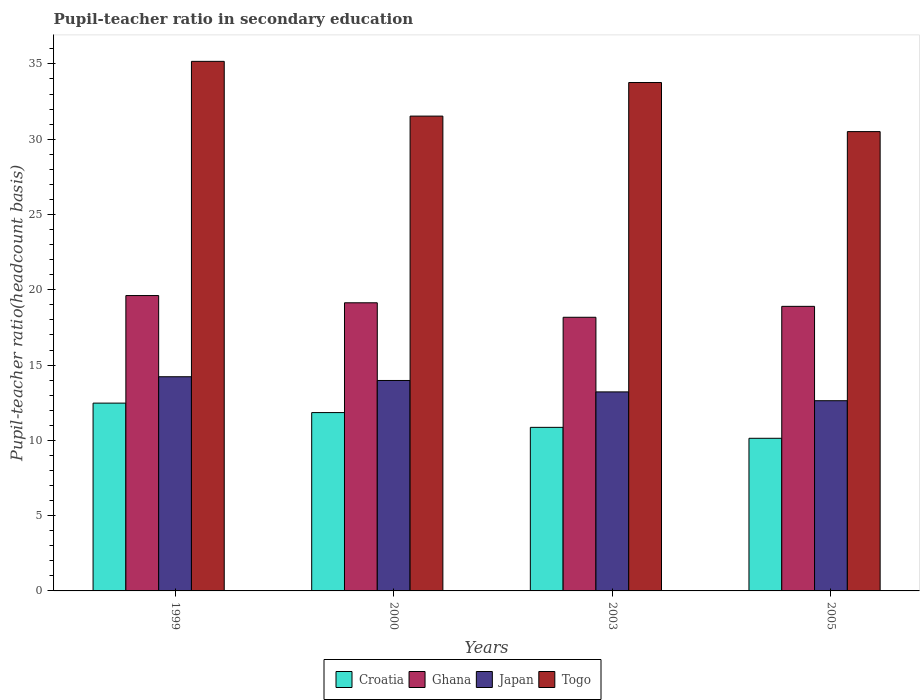Are the number of bars per tick equal to the number of legend labels?
Offer a terse response. Yes. Are the number of bars on each tick of the X-axis equal?
Offer a very short reply. Yes. How many bars are there on the 1st tick from the left?
Provide a short and direct response. 4. How many bars are there on the 3rd tick from the right?
Your response must be concise. 4. In how many cases, is the number of bars for a given year not equal to the number of legend labels?
Give a very brief answer. 0. What is the pupil-teacher ratio in secondary education in Croatia in 2003?
Ensure brevity in your answer.  10.86. Across all years, what is the maximum pupil-teacher ratio in secondary education in Japan?
Offer a terse response. 14.22. Across all years, what is the minimum pupil-teacher ratio in secondary education in Ghana?
Provide a succinct answer. 18.17. What is the total pupil-teacher ratio in secondary education in Japan in the graph?
Keep it short and to the point. 54.05. What is the difference between the pupil-teacher ratio in secondary education in Ghana in 1999 and that in 2005?
Ensure brevity in your answer.  0.72. What is the difference between the pupil-teacher ratio in secondary education in Croatia in 2003 and the pupil-teacher ratio in secondary education in Togo in 2005?
Provide a succinct answer. -19.64. What is the average pupil-teacher ratio in secondary education in Togo per year?
Make the answer very short. 32.74. In the year 2000, what is the difference between the pupil-teacher ratio in secondary education in Japan and pupil-teacher ratio in secondary education in Ghana?
Your answer should be very brief. -5.16. What is the ratio of the pupil-teacher ratio in secondary education in Japan in 2003 to that in 2005?
Make the answer very short. 1.05. What is the difference between the highest and the second highest pupil-teacher ratio in secondary education in Togo?
Offer a terse response. 1.41. What is the difference between the highest and the lowest pupil-teacher ratio in secondary education in Japan?
Provide a succinct answer. 1.59. In how many years, is the pupil-teacher ratio in secondary education in Ghana greater than the average pupil-teacher ratio in secondary education in Ghana taken over all years?
Keep it short and to the point. 2. What does the 3rd bar from the left in 2000 represents?
Your response must be concise. Japan. How many years are there in the graph?
Ensure brevity in your answer.  4. Does the graph contain any zero values?
Provide a short and direct response. No. Where does the legend appear in the graph?
Your answer should be very brief. Bottom center. How many legend labels are there?
Your response must be concise. 4. What is the title of the graph?
Make the answer very short. Pupil-teacher ratio in secondary education. Does "Marshall Islands" appear as one of the legend labels in the graph?
Provide a short and direct response. No. What is the label or title of the Y-axis?
Keep it short and to the point. Pupil-teacher ratio(headcount basis). What is the Pupil-teacher ratio(headcount basis) of Croatia in 1999?
Offer a very short reply. 12.47. What is the Pupil-teacher ratio(headcount basis) in Ghana in 1999?
Provide a succinct answer. 19.62. What is the Pupil-teacher ratio(headcount basis) of Japan in 1999?
Offer a terse response. 14.22. What is the Pupil-teacher ratio(headcount basis) in Togo in 1999?
Ensure brevity in your answer.  35.17. What is the Pupil-teacher ratio(headcount basis) of Croatia in 2000?
Give a very brief answer. 11.84. What is the Pupil-teacher ratio(headcount basis) in Ghana in 2000?
Make the answer very short. 19.14. What is the Pupil-teacher ratio(headcount basis) in Japan in 2000?
Offer a terse response. 13.98. What is the Pupil-teacher ratio(headcount basis) of Togo in 2000?
Make the answer very short. 31.53. What is the Pupil-teacher ratio(headcount basis) of Croatia in 2003?
Make the answer very short. 10.86. What is the Pupil-teacher ratio(headcount basis) of Ghana in 2003?
Give a very brief answer. 18.17. What is the Pupil-teacher ratio(headcount basis) in Japan in 2003?
Keep it short and to the point. 13.22. What is the Pupil-teacher ratio(headcount basis) of Togo in 2003?
Your answer should be compact. 33.76. What is the Pupil-teacher ratio(headcount basis) of Croatia in 2005?
Your response must be concise. 10.14. What is the Pupil-teacher ratio(headcount basis) of Ghana in 2005?
Offer a very short reply. 18.9. What is the Pupil-teacher ratio(headcount basis) of Japan in 2005?
Offer a very short reply. 12.63. What is the Pupil-teacher ratio(headcount basis) of Togo in 2005?
Offer a terse response. 30.51. Across all years, what is the maximum Pupil-teacher ratio(headcount basis) of Croatia?
Your answer should be very brief. 12.47. Across all years, what is the maximum Pupil-teacher ratio(headcount basis) in Ghana?
Provide a succinct answer. 19.62. Across all years, what is the maximum Pupil-teacher ratio(headcount basis) in Japan?
Make the answer very short. 14.22. Across all years, what is the maximum Pupil-teacher ratio(headcount basis) in Togo?
Ensure brevity in your answer.  35.17. Across all years, what is the minimum Pupil-teacher ratio(headcount basis) in Croatia?
Ensure brevity in your answer.  10.14. Across all years, what is the minimum Pupil-teacher ratio(headcount basis) in Ghana?
Offer a terse response. 18.17. Across all years, what is the minimum Pupil-teacher ratio(headcount basis) in Japan?
Give a very brief answer. 12.63. Across all years, what is the minimum Pupil-teacher ratio(headcount basis) of Togo?
Your response must be concise. 30.51. What is the total Pupil-teacher ratio(headcount basis) of Croatia in the graph?
Your response must be concise. 45.32. What is the total Pupil-teacher ratio(headcount basis) of Ghana in the graph?
Your answer should be compact. 75.83. What is the total Pupil-teacher ratio(headcount basis) of Japan in the graph?
Your answer should be compact. 54.05. What is the total Pupil-teacher ratio(headcount basis) of Togo in the graph?
Ensure brevity in your answer.  130.97. What is the difference between the Pupil-teacher ratio(headcount basis) in Croatia in 1999 and that in 2000?
Give a very brief answer. 0.63. What is the difference between the Pupil-teacher ratio(headcount basis) in Ghana in 1999 and that in 2000?
Keep it short and to the point. 0.48. What is the difference between the Pupil-teacher ratio(headcount basis) of Japan in 1999 and that in 2000?
Keep it short and to the point. 0.25. What is the difference between the Pupil-teacher ratio(headcount basis) of Togo in 1999 and that in 2000?
Provide a short and direct response. 3.64. What is the difference between the Pupil-teacher ratio(headcount basis) in Croatia in 1999 and that in 2003?
Give a very brief answer. 1.61. What is the difference between the Pupil-teacher ratio(headcount basis) in Ghana in 1999 and that in 2003?
Provide a succinct answer. 1.44. What is the difference between the Pupil-teacher ratio(headcount basis) of Togo in 1999 and that in 2003?
Your response must be concise. 1.41. What is the difference between the Pupil-teacher ratio(headcount basis) of Croatia in 1999 and that in 2005?
Offer a very short reply. 2.34. What is the difference between the Pupil-teacher ratio(headcount basis) of Ghana in 1999 and that in 2005?
Your answer should be very brief. 0.72. What is the difference between the Pupil-teacher ratio(headcount basis) of Japan in 1999 and that in 2005?
Your response must be concise. 1.59. What is the difference between the Pupil-teacher ratio(headcount basis) of Togo in 1999 and that in 2005?
Your response must be concise. 4.67. What is the difference between the Pupil-teacher ratio(headcount basis) of Croatia in 2000 and that in 2003?
Make the answer very short. 0.98. What is the difference between the Pupil-teacher ratio(headcount basis) of Ghana in 2000 and that in 2003?
Keep it short and to the point. 0.96. What is the difference between the Pupil-teacher ratio(headcount basis) in Japan in 2000 and that in 2003?
Ensure brevity in your answer.  0.76. What is the difference between the Pupil-teacher ratio(headcount basis) of Togo in 2000 and that in 2003?
Offer a very short reply. -2.23. What is the difference between the Pupil-teacher ratio(headcount basis) of Croatia in 2000 and that in 2005?
Provide a short and direct response. 1.71. What is the difference between the Pupil-teacher ratio(headcount basis) in Ghana in 2000 and that in 2005?
Provide a short and direct response. 0.24. What is the difference between the Pupil-teacher ratio(headcount basis) in Japan in 2000 and that in 2005?
Your response must be concise. 1.34. What is the difference between the Pupil-teacher ratio(headcount basis) in Togo in 2000 and that in 2005?
Ensure brevity in your answer.  1.03. What is the difference between the Pupil-teacher ratio(headcount basis) of Croatia in 2003 and that in 2005?
Provide a short and direct response. 0.73. What is the difference between the Pupil-teacher ratio(headcount basis) in Ghana in 2003 and that in 2005?
Give a very brief answer. -0.73. What is the difference between the Pupil-teacher ratio(headcount basis) of Japan in 2003 and that in 2005?
Give a very brief answer. 0.59. What is the difference between the Pupil-teacher ratio(headcount basis) of Togo in 2003 and that in 2005?
Provide a succinct answer. 3.26. What is the difference between the Pupil-teacher ratio(headcount basis) of Croatia in 1999 and the Pupil-teacher ratio(headcount basis) of Ghana in 2000?
Offer a very short reply. -6.66. What is the difference between the Pupil-teacher ratio(headcount basis) in Croatia in 1999 and the Pupil-teacher ratio(headcount basis) in Japan in 2000?
Make the answer very short. -1.5. What is the difference between the Pupil-teacher ratio(headcount basis) in Croatia in 1999 and the Pupil-teacher ratio(headcount basis) in Togo in 2000?
Your response must be concise. -19.06. What is the difference between the Pupil-teacher ratio(headcount basis) in Ghana in 1999 and the Pupil-teacher ratio(headcount basis) in Japan in 2000?
Provide a succinct answer. 5.64. What is the difference between the Pupil-teacher ratio(headcount basis) in Ghana in 1999 and the Pupil-teacher ratio(headcount basis) in Togo in 2000?
Your answer should be very brief. -11.92. What is the difference between the Pupil-teacher ratio(headcount basis) in Japan in 1999 and the Pupil-teacher ratio(headcount basis) in Togo in 2000?
Give a very brief answer. -17.31. What is the difference between the Pupil-teacher ratio(headcount basis) of Croatia in 1999 and the Pupil-teacher ratio(headcount basis) of Ghana in 2003?
Give a very brief answer. -5.7. What is the difference between the Pupil-teacher ratio(headcount basis) in Croatia in 1999 and the Pupil-teacher ratio(headcount basis) in Japan in 2003?
Make the answer very short. -0.75. What is the difference between the Pupil-teacher ratio(headcount basis) in Croatia in 1999 and the Pupil-teacher ratio(headcount basis) in Togo in 2003?
Provide a short and direct response. -21.29. What is the difference between the Pupil-teacher ratio(headcount basis) in Ghana in 1999 and the Pupil-teacher ratio(headcount basis) in Japan in 2003?
Provide a succinct answer. 6.4. What is the difference between the Pupil-teacher ratio(headcount basis) of Ghana in 1999 and the Pupil-teacher ratio(headcount basis) of Togo in 2003?
Give a very brief answer. -14.15. What is the difference between the Pupil-teacher ratio(headcount basis) in Japan in 1999 and the Pupil-teacher ratio(headcount basis) in Togo in 2003?
Give a very brief answer. -19.54. What is the difference between the Pupil-teacher ratio(headcount basis) of Croatia in 1999 and the Pupil-teacher ratio(headcount basis) of Ghana in 2005?
Provide a short and direct response. -6.43. What is the difference between the Pupil-teacher ratio(headcount basis) of Croatia in 1999 and the Pupil-teacher ratio(headcount basis) of Japan in 2005?
Your response must be concise. -0.16. What is the difference between the Pupil-teacher ratio(headcount basis) in Croatia in 1999 and the Pupil-teacher ratio(headcount basis) in Togo in 2005?
Your answer should be compact. -18.03. What is the difference between the Pupil-teacher ratio(headcount basis) of Ghana in 1999 and the Pupil-teacher ratio(headcount basis) of Japan in 2005?
Offer a very short reply. 6.98. What is the difference between the Pupil-teacher ratio(headcount basis) of Ghana in 1999 and the Pupil-teacher ratio(headcount basis) of Togo in 2005?
Keep it short and to the point. -10.89. What is the difference between the Pupil-teacher ratio(headcount basis) of Japan in 1999 and the Pupil-teacher ratio(headcount basis) of Togo in 2005?
Provide a short and direct response. -16.28. What is the difference between the Pupil-teacher ratio(headcount basis) of Croatia in 2000 and the Pupil-teacher ratio(headcount basis) of Ghana in 2003?
Provide a succinct answer. -6.33. What is the difference between the Pupil-teacher ratio(headcount basis) of Croatia in 2000 and the Pupil-teacher ratio(headcount basis) of Japan in 2003?
Offer a terse response. -1.37. What is the difference between the Pupil-teacher ratio(headcount basis) of Croatia in 2000 and the Pupil-teacher ratio(headcount basis) of Togo in 2003?
Offer a very short reply. -21.92. What is the difference between the Pupil-teacher ratio(headcount basis) in Ghana in 2000 and the Pupil-teacher ratio(headcount basis) in Japan in 2003?
Make the answer very short. 5.92. What is the difference between the Pupil-teacher ratio(headcount basis) in Ghana in 2000 and the Pupil-teacher ratio(headcount basis) in Togo in 2003?
Ensure brevity in your answer.  -14.63. What is the difference between the Pupil-teacher ratio(headcount basis) in Japan in 2000 and the Pupil-teacher ratio(headcount basis) in Togo in 2003?
Your answer should be compact. -19.79. What is the difference between the Pupil-teacher ratio(headcount basis) in Croatia in 2000 and the Pupil-teacher ratio(headcount basis) in Ghana in 2005?
Provide a succinct answer. -7.06. What is the difference between the Pupil-teacher ratio(headcount basis) in Croatia in 2000 and the Pupil-teacher ratio(headcount basis) in Japan in 2005?
Offer a terse response. -0.79. What is the difference between the Pupil-teacher ratio(headcount basis) of Croatia in 2000 and the Pupil-teacher ratio(headcount basis) of Togo in 2005?
Your response must be concise. -18.66. What is the difference between the Pupil-teacher ratio(headcount basis) in Ghana in 2000 and the Pupil-teacher ratio(headcount basis) in Japan in 2005?
Provide a succinct answer. 6.5. What is the difference between the Pupil-teacher ratio(headcount basis) in Ghana in 2000 and the Pupil-teacher ratio(headcount basis) in Togo in 2005?
Offer a terse response. -11.37. What is the difference between the Pupil-teacher ratio(headcount basis) of Japan in 2000 and the Pupil-teacher ratio(headcount basis) of Togo in 2005?
Make the answer very short. -16.53. What is the difference between the Pupil-teacher ratio(headcount basis) in Croatia in 2003 and the Pupil-teacher ratio(headcount basis) in Ghana in 2005?
Give a very brief answer. -8.04. What is the difference between the Pupil-teacher ratio(headcount basis) of Croatia in 2003 and the Pupil-teacher ratio(headcount basis) of Japan in 2005?
Provide a succinct answer. -1.77. What is the difference between the Pupil-teacher ratio(headcount basis) of Croatia in 2003 and the Pupil-teacher ratio(headcount basis) of Togo in 2005?
Offer a very short reply. -19.64. What is the difference between the Pupil-teacher ratio(headcount basis) of Ghana in 2003 and the Pupil-teacher ratio(headcount basis) of Japan in 2005?
Your response must be concise. 5.54. What is the difference between the Pupil-teacher ratio(headcount basis) of Ghana in 2003 and the Pupil-teacher ratio(headcount basis) of Togo in 2005?
Provide a succinct answer. -12.33. What is the difference between the Pupil-teacher ratio(headcount basis) of Japan in 2003 and the Pupil-teacher ratio(headcount basis) of Togo in 2005?
Give a very brief answer. -17.29. What is the average Pupil-teacher ratio(headcount basis) of Croatia per year?
Provide a short and direct response. 11.33. What is the average Pupil-teacher ratio(headcount basis) of Ghana per year?
Provide a succinct answer. 18.96. What is the average Pupil-teacher ratio(headcount basis) in Japan per year?
Give a very brief answer. 13.51. What is the average Pupil-teacher ratio(headcount basis) of Togo per year?
Provide a succinct answer. 32.74. In the year 1999, what is the difference between the Pupil-teacher ratio(headcount basis) of Croatia and Pupil-teacher ratio(headcount basis) of Ghana?
Your answer should be compact. -7.14. In the year 1999, what is the difference between the Pupil-teacher ratio(headcount basis) in Croatia and Pupil-teacher ratio(headcount basis) in Japan?
Your answer should be compact. -1.75. In the year 1999, what is the difference between the Pupil-teacher ratio(headcount basis) in Croatia and Pupil-teacher ratio(headcount basis) in Togo?
Your response must be concise. -22.7. In the year 1999, what is the difference between the Pupil-teacher ratio(headcount basis) of Ghana and Pupil-teacher ratio(headcount basis) of Japan?
Provide a short and direct response. 5.39. In the year 1999, what is the difference between the Pupil-teacher ratio(headcount basis) of Ghana and Pupil-teacher ratio(headcount basis) of Togo?
Offer a terse response. -15.55. In the year 1999, what is the difference between the Pupil-teacher ratio(headcount basis) of Japan and Pupil-teacher ratio(headcount basis) of Togo?
Your response must be concise. -20.95. In the year 2000, what is the difference between the Pupil-teacher ratio(headcount basis) in Croatia and Pupil-teacher ratio(headcount basis) in Ghana?
Provide a succinct answer. -7.29. In the year 2000, what is the difference between the Pupil-teacher ratio(headcount basis) in Croatia and Pupil-teacher ratio(headcount basis) in Japan?
Offer a terse response. -2.13. In the year 2000, what is the difference between the Pupil-teacher ratio(headcount basis) in Croatia and Pupil-teacher ratio(headcount basis) in Togo?
Give a very brief answer. -19.69. In the year 2000, what is the difference between the Pupil-teacher ratio(headcount basis) in Ghana and Pupil-teacher ratio(headcount basis) in Japan?
Provide a succinct answer. 5.16. In the year 2000, what is the difference between the Pupil-teacher ratio(headcount basis) of Ghana and Pupil-teacher ratio(headcount basis) of Togo?
Offer a very short reply. -12.4. In the year 2000, what is the difference between the Pupil-teacher ratio(headcount basis) of Japan and Pupil-teacher ratio(headcount basis) of Togo?
Your answer should be compact. -17.56. In the year 2003, what is the difference between the Pupil-teacher ratio(headcount basis) in Croatia and Pupil-teacher ratio(headcount basis) in Ghana?
Ensure brevity in your answer.  -7.31. In the year 2003, what is the difference between the Pupil-teacher ratio(headcount basis) in Croatia and Pupil-teacher ratio(headcount basis) in Japan?
Your response must be concise. -2.35. In the year 2003, what is the difference between the Pupil-teacher ratio(headcount basis) of Croatia and Pupil-teacher ratio(headcount basis) of Togo?
Offer a terse response. -22.9. In the year 2003, what is the difference between the Pupil-teacher ratio(headcount basis) in Ghana and Pupil-teacher ratio(headcount basis) in Japan?
Keep it short and to the point. 4.96. In the year 2003, what is the difference between the Pupil-teacher ratio(headcount basis) in Ghana and Pupil-teacher ratio(headcount basis) in Togo?
Offer a very short reply. -15.59. In the year 2003, what is the difference between the Pupil-teacher ratio(headcount basis) of Japan and Pupil-teacher ratio(headcount basis) of Togo?
Ensure brevity in your answer.  -20.55. In the year 2005, what is the difference between the Pupil-teacher ratio(headcount basis) in Croatia and Pupil-teacher ratio(headcount basis) in Ghana?
Offer a very short reply. -8.76. In the year 2005, what is the difference between the Pupil-teacher ratio(headcount basis) of Croatia and Pupil-teacher ratio(headcount basis) of Japan?
Offer a terse response. -2.5. In the year 2005, what is the difference between the Pupil-teacher ratio(headcount basis) of Croatia and Pupil-teacher ratio(headcount basis) of Togo?
Provide a short and direct response. -20.37. In the year 2005, what is the difference between the Pupil-teacher ratio(headcount basis) in Ghana and Pupil-teacher ratio(headcount basis) in Japan?
Provide a short and direct response. 6.27. In the year 2005, what is the difference between the Pupil-teacher ratio(headcount basis) of Ghana and Pupil-teacher ratio(headcount basis) of Togo?
Provide a succinct answer. -11.61. In the year 2005, what is the difference between the Pupil-teacher ratio(headcount basis) of Japan and Pupil-teacher ratio(headcount basis) of Togo?
Offer a terse response. -17.87. What is the ratio of the Pupil-teacher ratio(headcount basis) of Croatia in 1999 to that in 2000?
Provide a short and direct response. 1.05. What is the ratio of the Pupil-teacher ratio(headcount basis) of Ghana in 1999 to that in 2000?
Make the answer very short. 1.03. What is the ratio of the Pupil-teacher ratio(headcount basis) in Japan in 1999 to that in 2000?
Keep it short and to the point. 1.02. What is the ratio of the Pupil-teacher ratio(headcount basis) of Togo in 1999 to that in 2000?
Your answer should be compact. 1.12. What is the ratio of the Pupil-teacher ratio(headcount basis) of Croatia in 1999 to that in 2003?
Provide a succinct answer. 1.15. What is the ratio of the Pupil-teacher ratio(headcount basis) of Ghana in 1999 to that in 2003?
Your response must be concise. 1.08. What is the ratio of the Pupil-teacher ratio(headcount basis) of Japan in 1999 to that in 2003?
Ensure brevity in your answer.  1.08. What is the ratio of the Pupil-teacher ratio(headcount basis) in Togo in 1999 to that in 2003?
Provide a short and direct response. 1.04. What is the ratio of the Pupil-teacher ratio(headcount basis) in Croatia in 1999 to that in 2005?
Keep it short and to the point. 1.23. What is the ratio of the Pupil-teacher ratio(headcount basis) in Ghana in 1999 to that in 2005?
Provide a short and direct response. 1.04. What is the ratio of the Pupil-teacher ratio(headcount basis) of Japan in 1999 to that in 2005?
Provide a succinct answer. 1.13. What is the ratio of the Pupil-teacher ratio(headcount basis) of Togo in 1999 to that in 2005?
Ensure brevity in your answer.  1.15. What is the ratio of the Pupil-teacher ratio(headcount basis) in Croatia in 2000 to that in 2003?
Provide a succinct answer. 1.09. What is the ratio of the Pupil-teacher ratio(headcount basis) of Ghana in 2000 to that in 2003?
Provide a short and direct response. 1.05. What is the ratio of the Pupil-teacher ratio(headcount basis) in Japan in 2000 to that in 2003?
Provide a succinct answer. 1.06. What is the ratio of the Pupil-teacher ratio(headcount basis) in Togo in 2000 to that in 2003?
Offer a terse response. 0.93. What is the ratio of the Pupil-teacher ratio(headcount basis) of Croatia in 2000 to that in 2005?
Keep it short and to the point. 1.17. What is the ratio of the Pupil-teacher ratio(headcount basis) in Ghana in 2000 to that in 2005?
Make the answer very short. 1.01. What is the ratio of the Pupil-teacher ratio(headcount basis) of Japan in 2000 to that in 2005?
Give a very brief answer. 1.11. What is the ratio of the Pupil-teacher ratio(headcount basis) in Togo in 2000 to that in 2005?
Your answer should be compact. 1.03. What is the ratio of the Pupil-teacher ratio(headcount basis) in Croatia in 2003 to that in 2005?
Make the answer very short. 1.07. What is the ratio of the Pupil-teacher ratio(headcount basis) of Ghana in 2003 to that in 2005?
Keep it short and to the point. 0.96. What is the ratio of the Pupil-teacher ratio(headcount basis) in Japan in 2003 to that in 2005?
Your answer should be compact. 1.05. What is the ratio of the Pupil-teacher ratio(headcount basis) of Togo in 2003 to that in 2005?
Offer a very short reply. 1.11. What is the difference between the highest and the second highest Pupil-teacher ratio(headcount basis) in Croatia?
Your answer should be compact. 0.63. What is the difference between the highest and the second highest Pupil-teacher ratio(headcount basis) of Ghana?
Your answer should be very brief. 0.48. What is the difference between the highest and the second highest Pupil-teacher ratio(headcount basis) in Japan?
Your answer should be compact. 0.25. What is the difference between the highest and the second highest Pupil-teacher ratio(headcount basis) in Togo?
Offer a terse response. 1.41. What is the difference between the highest and the lowest Pupil-teacher ratio(headcount basis) of Croatia?
Make the answer very short. 2.34. What is the difference between the highest and the lowest Pupil-teacher ratio(headcount basis) of Ghana?
Your answer should be very brief. 1.44. What is the difference between the highest and the lowest Pupil-teacher ratio(headcount basis) of Japan?
Provide a short and direct response. 1.59. What is the difference between the highest and the lowest Pupil-teacher ratio(headcount basis) in Togo?
Ensure brevity in your answer.  4.67. 